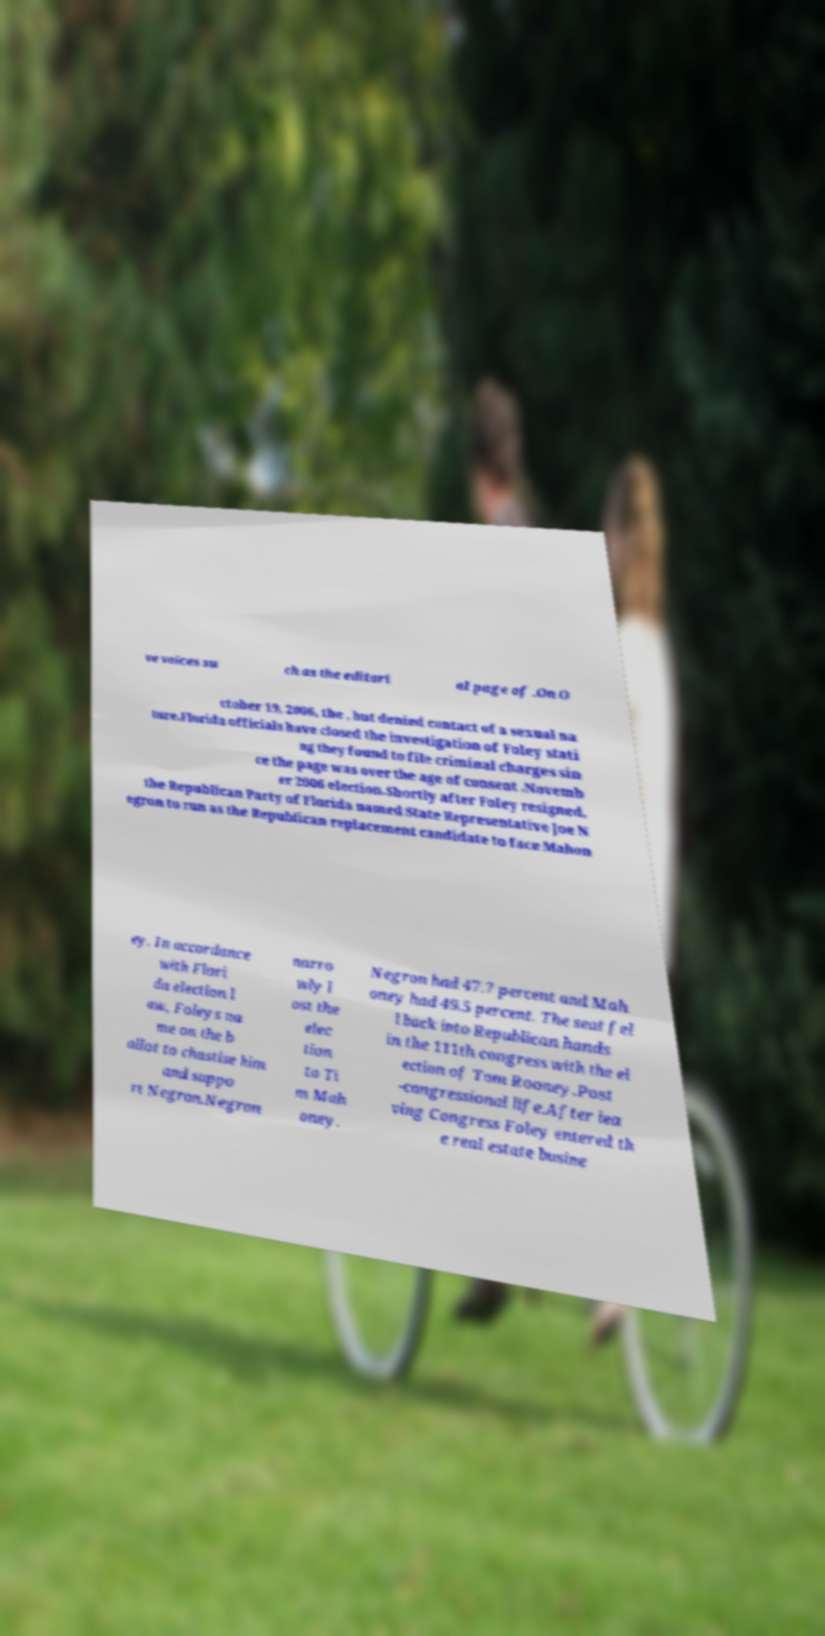There's text embedded in this image that I need extracted. Can you transcribe it verbatim? ve voices su ch as the editori al page of .On O ctober 19, 2006, the , but denied contact of a sexual na ture.Florida officials have closed the investigation of Foley stati ng they found to file criminal charges sin ce the page was over the age of consent .Novemb er 2006 election.Shortly after Foley resigned, the Republican Party of Florida named State Representative Joe N egron to run as the Republican replacement candidate to face Mahon ey. In accordance with Flori da election l aw, Foleys na me on the b allot to chastise him and suppo rt Negron.Negron narro wly l ost the elec tion to Ti m Mah oney. Negron had 47.7 percent and Mah oney had 49.5 percent. The seat fel l back into Republican hands in the 111th congress with the el ection of Tom Rooney.Post -congressional life.After lea ving Congress Foley entered th e real estate busine 